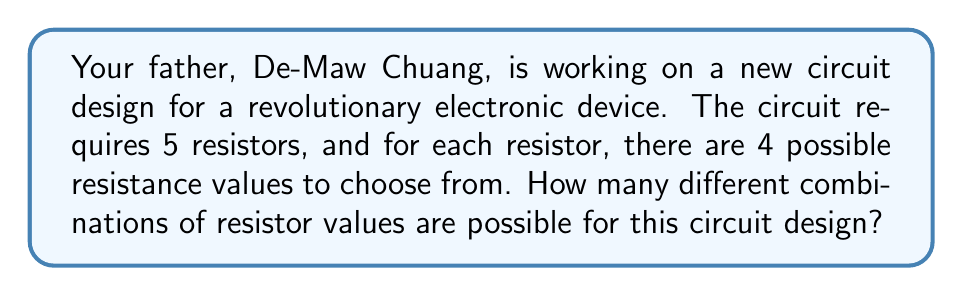Provide a solution to this math problem. Let's approach this step-by-step:

1) We have 5 positions in the circuit that need to be filled with resistors.

2) For each position, we have 4 choices of resistance values.

3) This scenario is a perfect example of the Multiplication Principle in combinatorics. When we have a series of independent choices, the total number of possible outcomes is the product of the number of choices for each decision.

4) In this case, we're making 5 independent decisions (one for each resistor), and each decision has 4 possible outcomes.

5) Therefore, the total number of possible combinations is:

   $$ 4 \times 4 \times 4 \times 4 \times 4 = 4^5 $$

6) We can calculate this:

   $$ 4^5 = 4 \times 4 \times 4 \times 4 \times 4 = 1024 $$

Thus, there are 1024 different possible combinations of resistor values for your father's circuit design.
Answer: 1024 